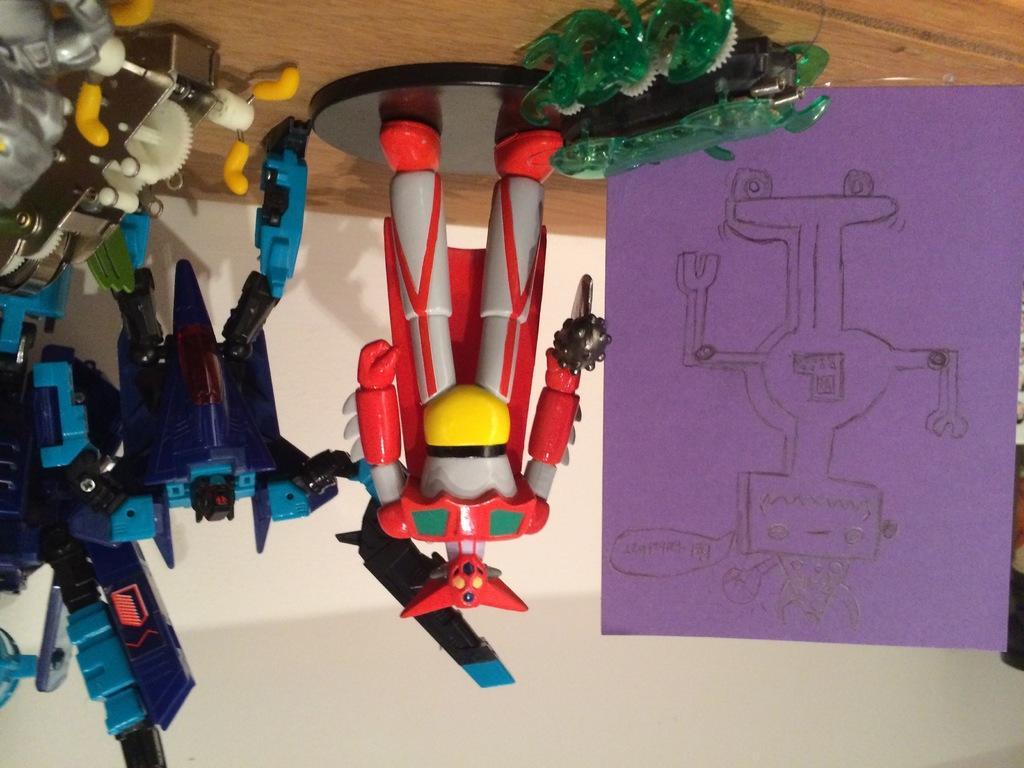How would you summarize this image in a sentence or two? In the image in the center, we can see different color toys and paper. In the background there is a wall. 